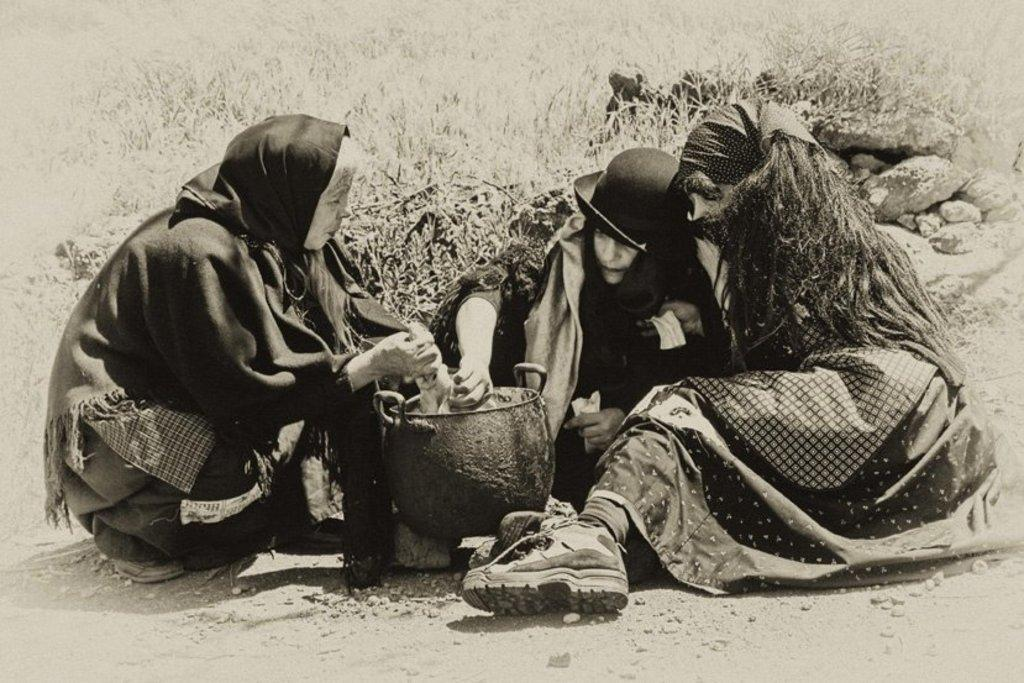What can be seen in the image regarding people? There are persons wearing clothes in the image. What is located in the middle of the image? There is a dish in the middle of the image. What type of vegetation is present at the top of the image? There are plants at the top of the image. What is the condition of the seashore in the image? There is no seashore present in the image. Is there a ring visible on any of the persons in the image? There is no mention of a ring in the provided facts, so it cannot be determined if one is visible. 